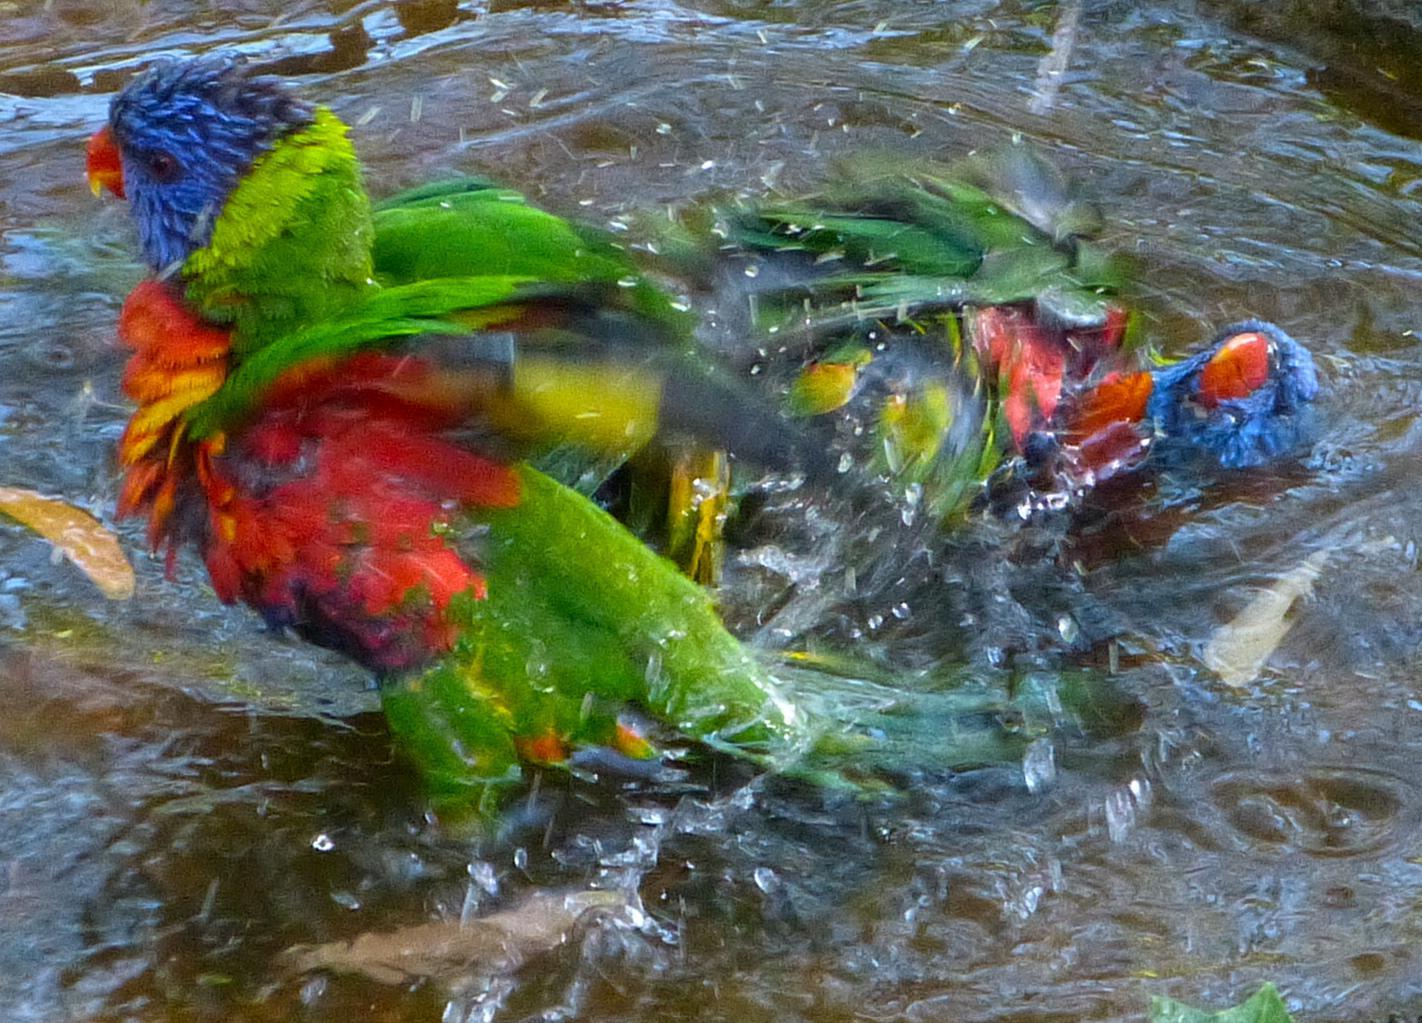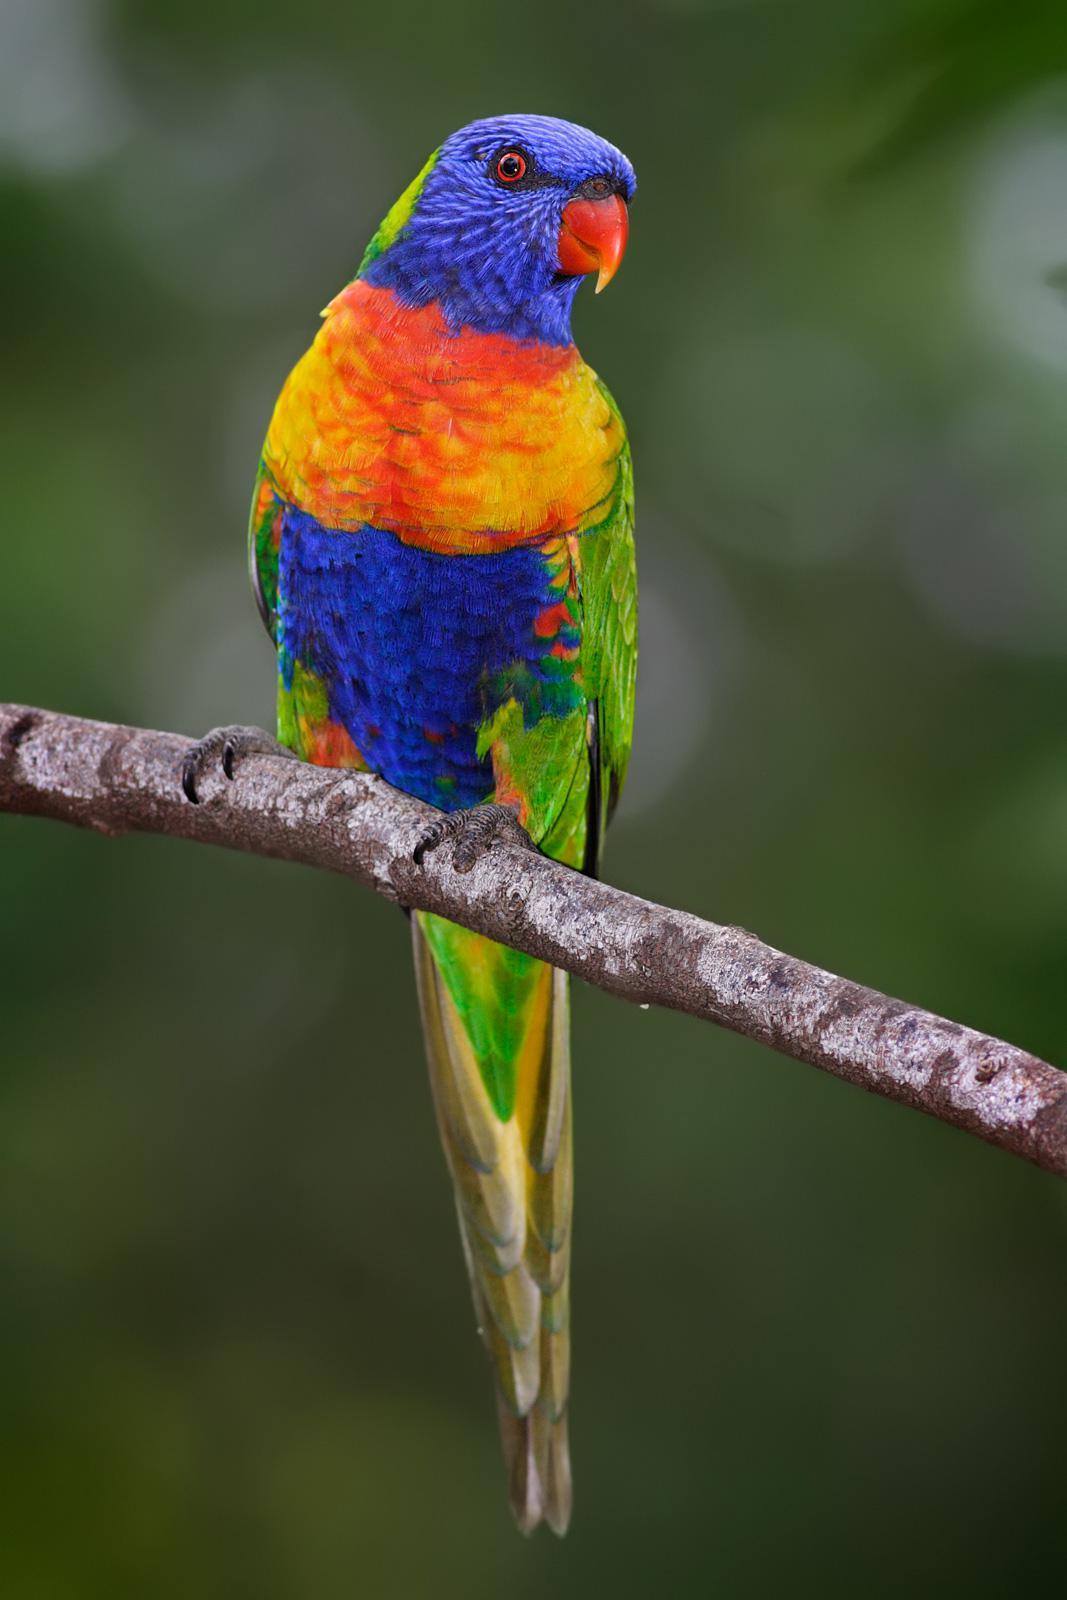The first image is the image on the left, the second image is the image on the right. Examine the images to the left and right. Is the description "There's no more than one parrot in the right image." accurate? Answer yes or no. Yes. The first image is the image on the left, the second image is the image on the right. Considering the images on both sides, is "An image features a horizontal row of at least four perched blue-headed parrots." valid? Answer yes or no. No. 